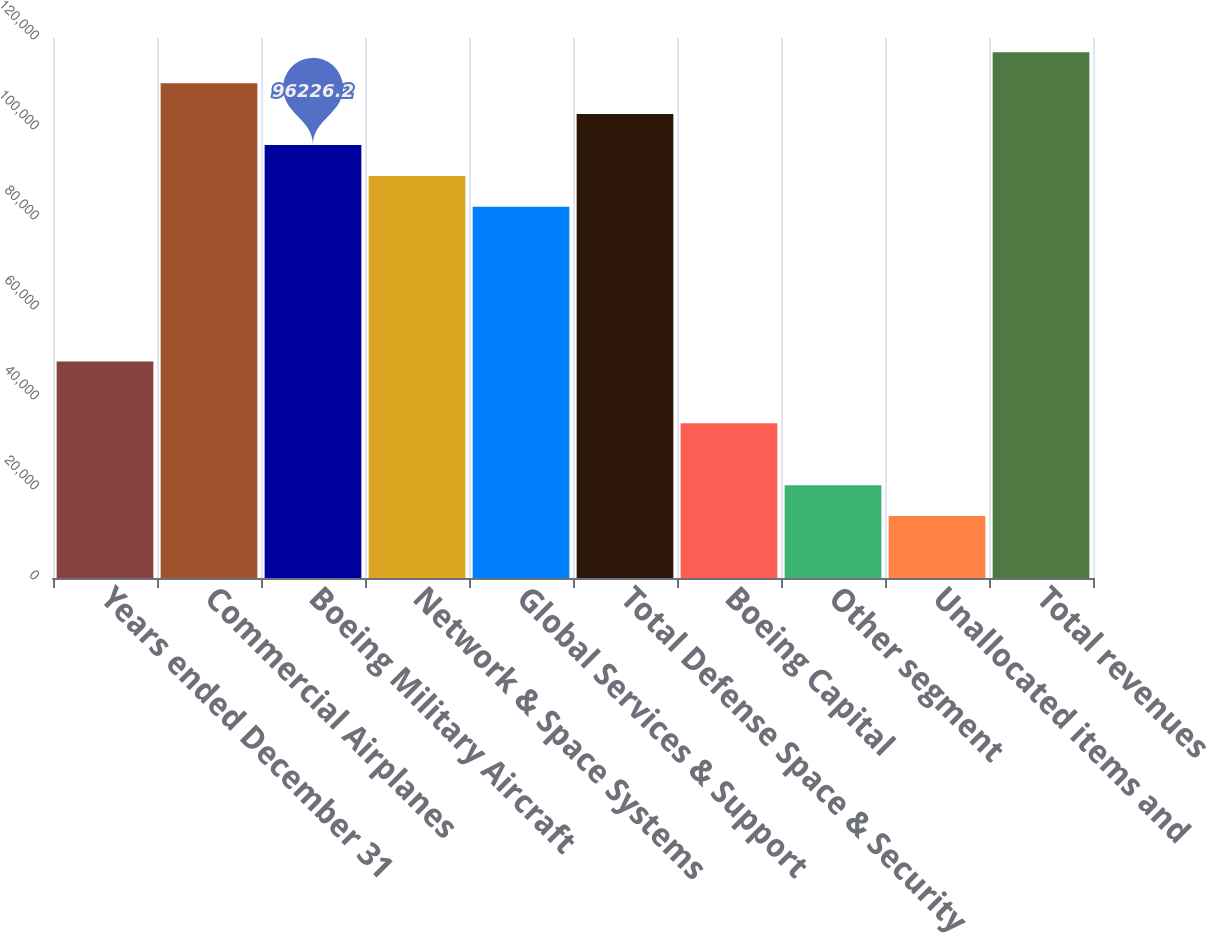Convert chart. <chart><loc_0><loc_0><loc_500><loc_500><bar_chart><fcel>Years ended December 31<fcel>Commercial Airplanes<fcel>Boeing Military Aircraft<fcel>Network & Space Systems<fcel>Global Services & Support<fcel>Total Defense Space & Security<fcel>Boeing Capital<fcel>Other segment<fcel>Unallocated items and<fcel>Total revenues<nl><fcel>48116.6<fcel>109972<fcel>96226.2<fcel>89353.4<fcel>82480.6<fcel>103099<fcel>34371<fcel>20625.4<fcel>13752.6<fcel>116845<nl></chart> 